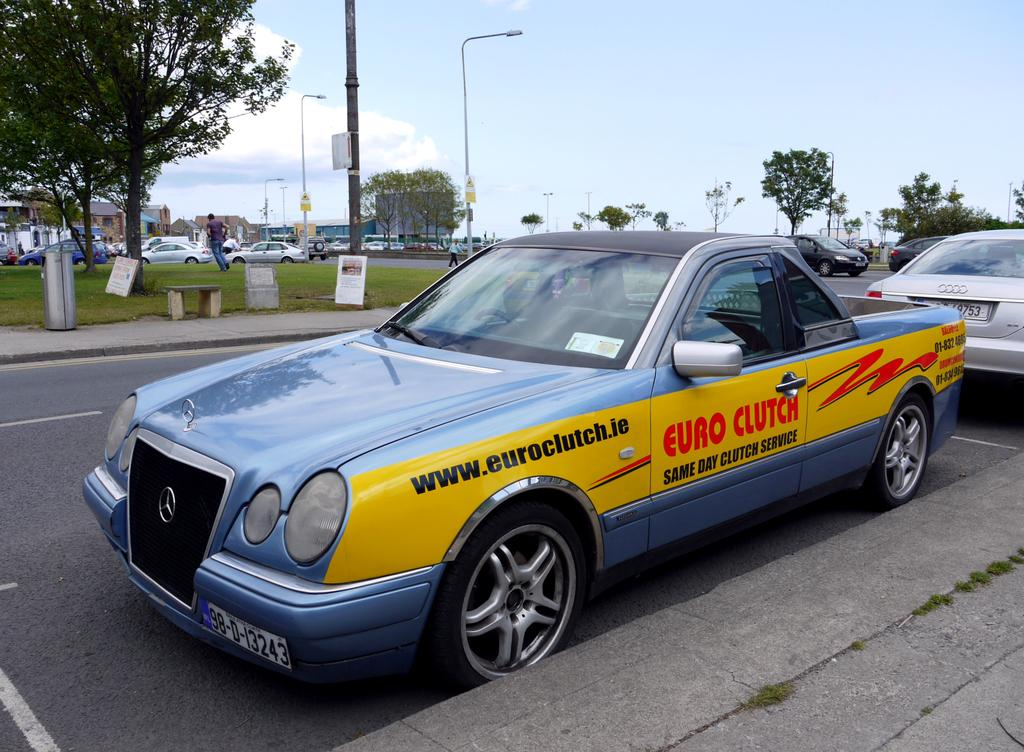Provide a one-sentence caption for the provided image. A pickup truck has the web address www.euroclutch.ie on the side. 